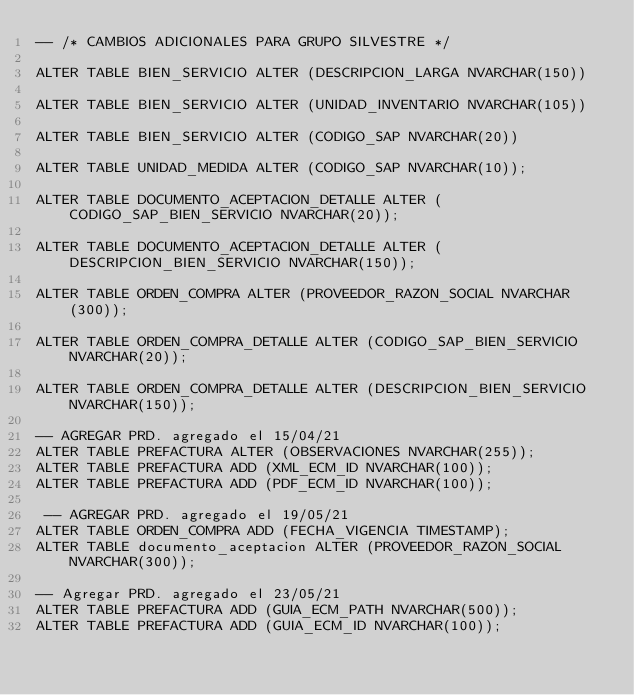Convert code to text. <code><loc_0><loc_0><loc_500><loc_500><_SQL_>-- /* CAMBIOS ADICIONALES PARA GRUPO SILVESTRE */

ALTER TABLE BIEN_SERVICIO ALTER (DESCRIPCION_LARGA NVARCHAR(150))

ALTER TABLE BIEN_SERVICIO ALTER (UNIDAD_INVENTARIO NVARCHAR(105))

ALTER TABLE BIEN_SERVICIO ALTER (CODIGO_SAP NVARCHAR(20))

ALTER TABLE UNIDAD_MEDIDA ALTER (CODIGO_SAP NVARCHAR(10));

ALTER TABLE DOCUMENTO_ACEPTACION_DETALLE ALTER (CODIGO_SAP_BIEN_SERVICIO NVARCHAR(20));

ALTER TABLE DOCUMENTO_ACEPTACION_DETALLE ALTER (DESCRIPCION_BIEN_SERVICIO NVARCHAR(150));

ALTER TABLE ORDEN_COMPRA ALTER (PROVEEDOR_RAZON_SOCIAL NVARCHAR(300));

ALTER TABLE ORDEN_COMPRA_DETALLE ALTER (CODIGO_SAP_BIEN_SERVICIO NVARCHAR(20));

ALTER TABLE ORDEN_COMPRA_DETALLE ALTER (DESCRIPCION_BIEN_SERVICIO NVARCHAR(150));

-- AGREGAR PRD. agregado el 15/04/21
ALTER TABLE PREFACTURA ALTER (OBSERVACIONES NVARCHAR(255));
ALTER TABLE PREFACTURA ADD (XML_ECM_ID NVARCHAR(100));
ALTER TABLE PREFACTURA ADD (PDF_ECM_ID NVARCHAR(100));

 -- AGREGAR PRD. agregado el 19/05/21
ALTER TABLE ORDEN_COMPRA ADD (FECHA_VIGENCIA TIMESTAMP);
ALTER TABLE documento_aceptacion ALTER (PROVEEDOR_RAZON_SOCIAL NVARCHAR(300));

-- Agregar PRD. agregado el 23/05/21
ALTER TABLE PREFACTURA ADD (GUIA_ECM_PATH NVARCHAR(500));
ALTER TABLE PREFACTURA ADD (GUIA_ECM_ID NVARCHAR(100));</code> 